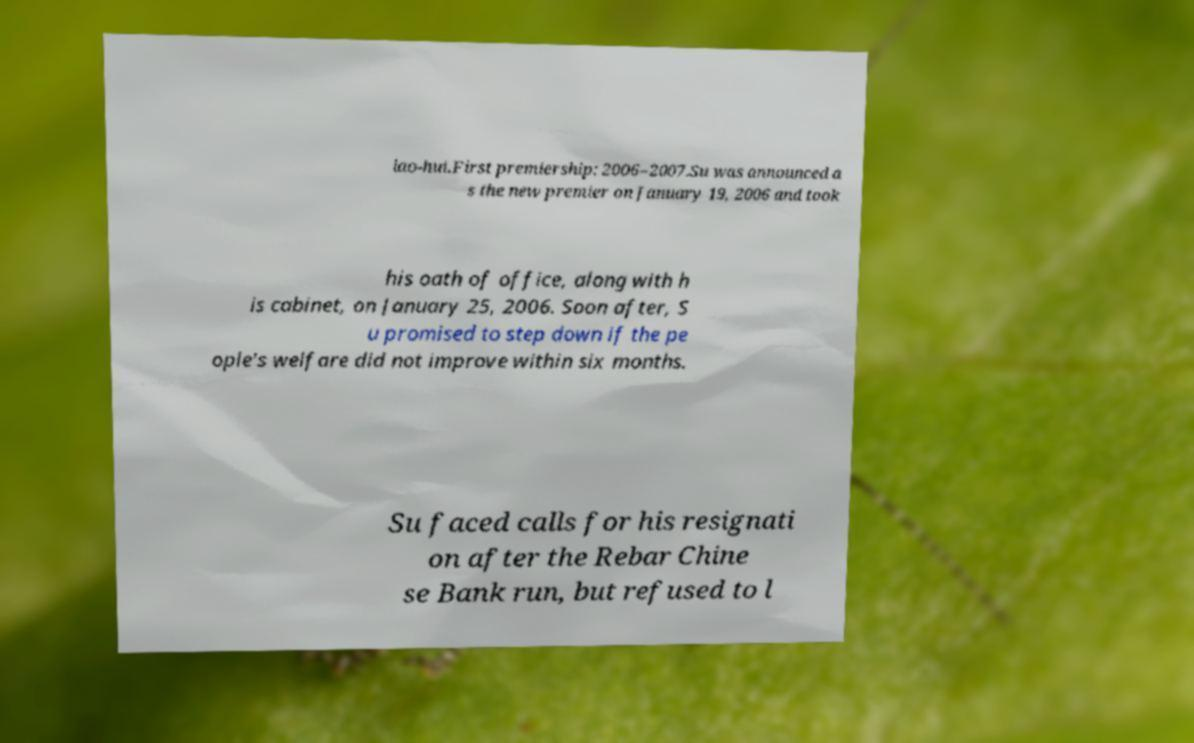There's text embedded in this image that I need extracted. Can you transcribe it verbatim? iao-hui.First premiership: 2006–2007.Su was announced a s the new premier on January 19, 2006 and took his oath of office, along with h is cabinet, on January 25, 2006. Soon after, S u promised to step down if the pe ople's welfare did not improve within six months. Su faced calls for his resignati on after the Rebar Chine se Bank run, but refused to l 